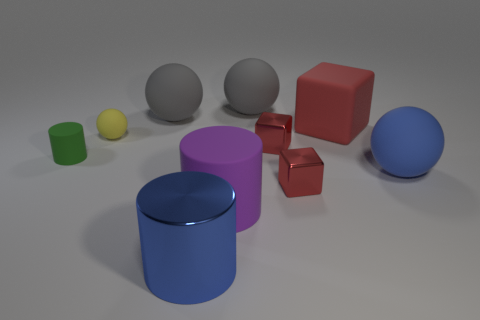How many things are either big cylinders right of the blue cylinder or big objects behind the green rubber cylinder?
Give a very brief answer. 4. What number of small objects are both in front of the yellow matte sphere and to the right of the tiny cylinder?
Offer a very short reply. 2. Do the yellow object and the green cylinder have the same material?
Provide a succinct answer. Yes. The large blue thing that is right of the red metallic object that is in front of the big matte sphere that is in front of the green object is what shape?
Your answer should be compact. Sphere. There is a sphere that is both right of the purple matte thing and on the left side of the large cube; what is it made of?
Provide a succinct answer. Rubber. There is a tiny rubber thing that is behind the red metal object behind the large matte ball that is on the right side of the rubber cube; what is its color?
Provide a succinct answer. Yellow. What number of purple things are small spheres or small metallic objects?
Offer a terse response. 0. How many other things are there of the same size as the yellow matte object?
Your answer should be very brief. 3. What number of metallic blocks are there?
Make the answer very short. 2. Are there any other things that are the same shape as the big red matte object?
Provide a succinct answer. Yes. 